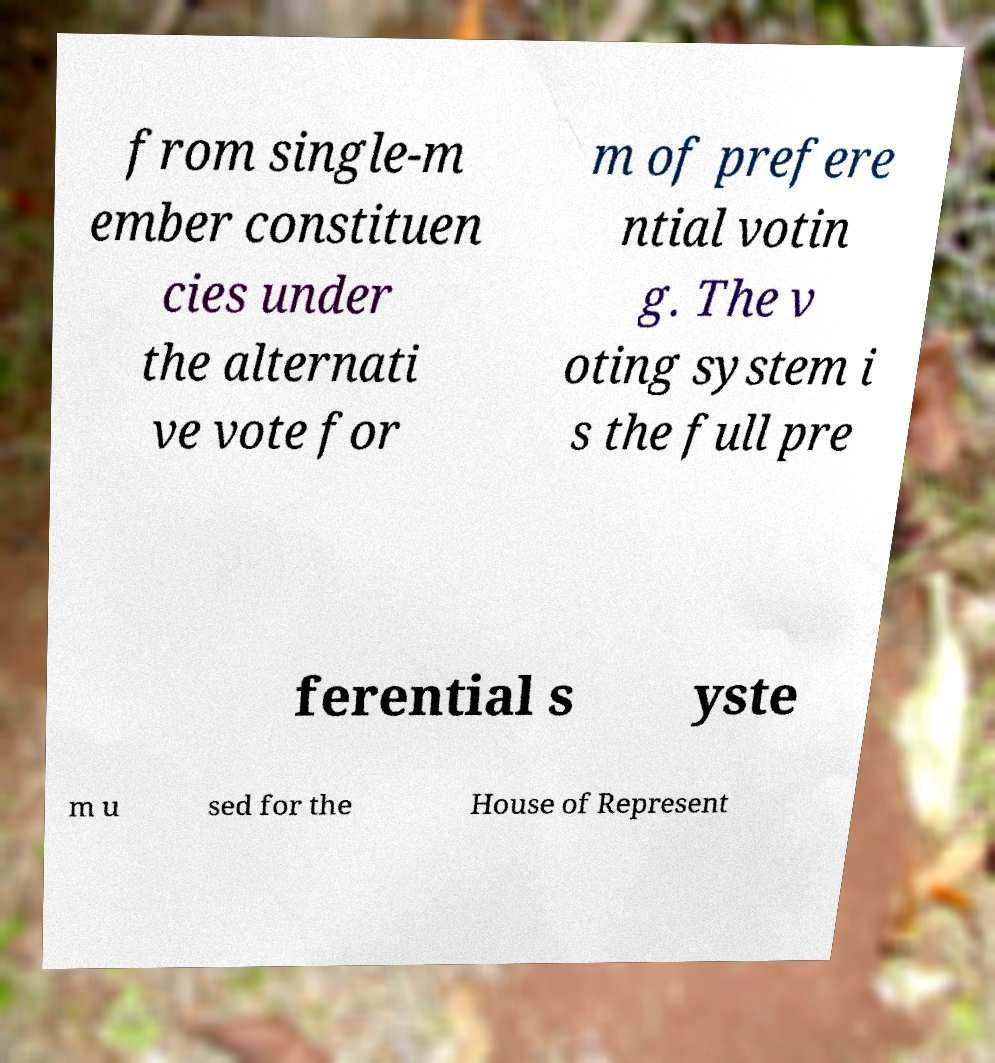There's text embedded in this image that I need extracted. Can you transcribe it verbatim? from single-m ember constituen cies under the alternati ve vote for m of prefere ntial votin g. The v oting system i s the full pre ferential s yste m u sed for the House of Represent 